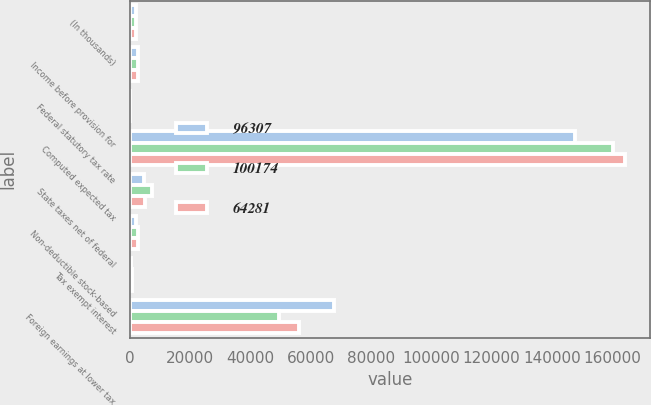Convert chart to OTSL. <chart><loc_0><loc_0><loc_500><loc_500><stacked_bar_chart><ecel><fcel>(In thousands)<fcel>Income before provision for<fcel>Federal statutory tax rate<fcel>Computed expected tax<fcel>State taxes net of federal<fcel>Non-deductible stock-based<fcel>Tax exempt interest<fcel>Foreign earnings at lower tax<nl><fcel>96307<fcel>2010<fcel>2550<fcel>35<fcel>147618<fcel>4527<fcel>1813<fcel>396<fcel>67651<nl><fcel>100174<fcel>2009<fcel>2550<fcel>35<fcel>160309<fcel>7292<fcel>2550<fcel>567<fcel>49446<nl><fcel>64281<fcel>2008<fcel>2550<fcel>35<fcel>164321<fcel>4970<fcel>2676<fcel>721<fcel>55949<nl></chart> 